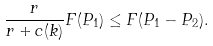Convert formula to latex. <formula><loc_0><loc_0><loc_500><loc_500>\frac { r } { r + c ( k ) } F ( P _ { 1 } ) \leq F ( P _ { 1 } - P _ { 2 } ) .</formula> 